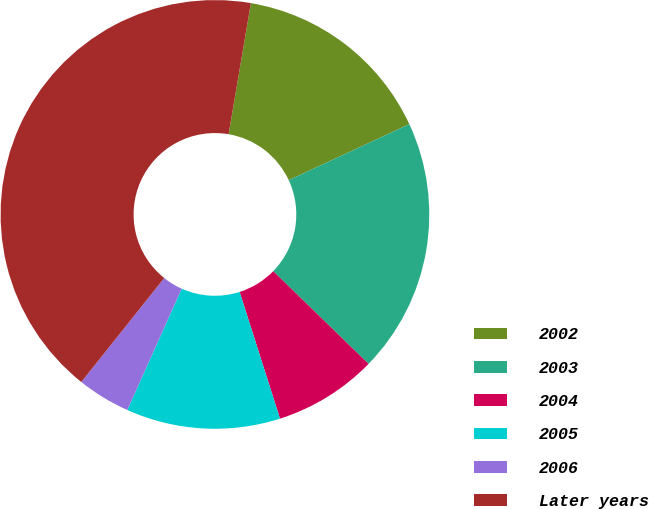<chart> <loc_0><loc_0><loc_500><loc_500><pie_chart><fcel>2002<fcel>2003<fcel>2004<fcel>2005<fcel>2006<fcel>Later years<nl><fcel>15.4%<fcel>19.2%<fcel>7.81%<fcel>11.61%<fcel>4.01%<fcel>41.97%<nl></chart> 